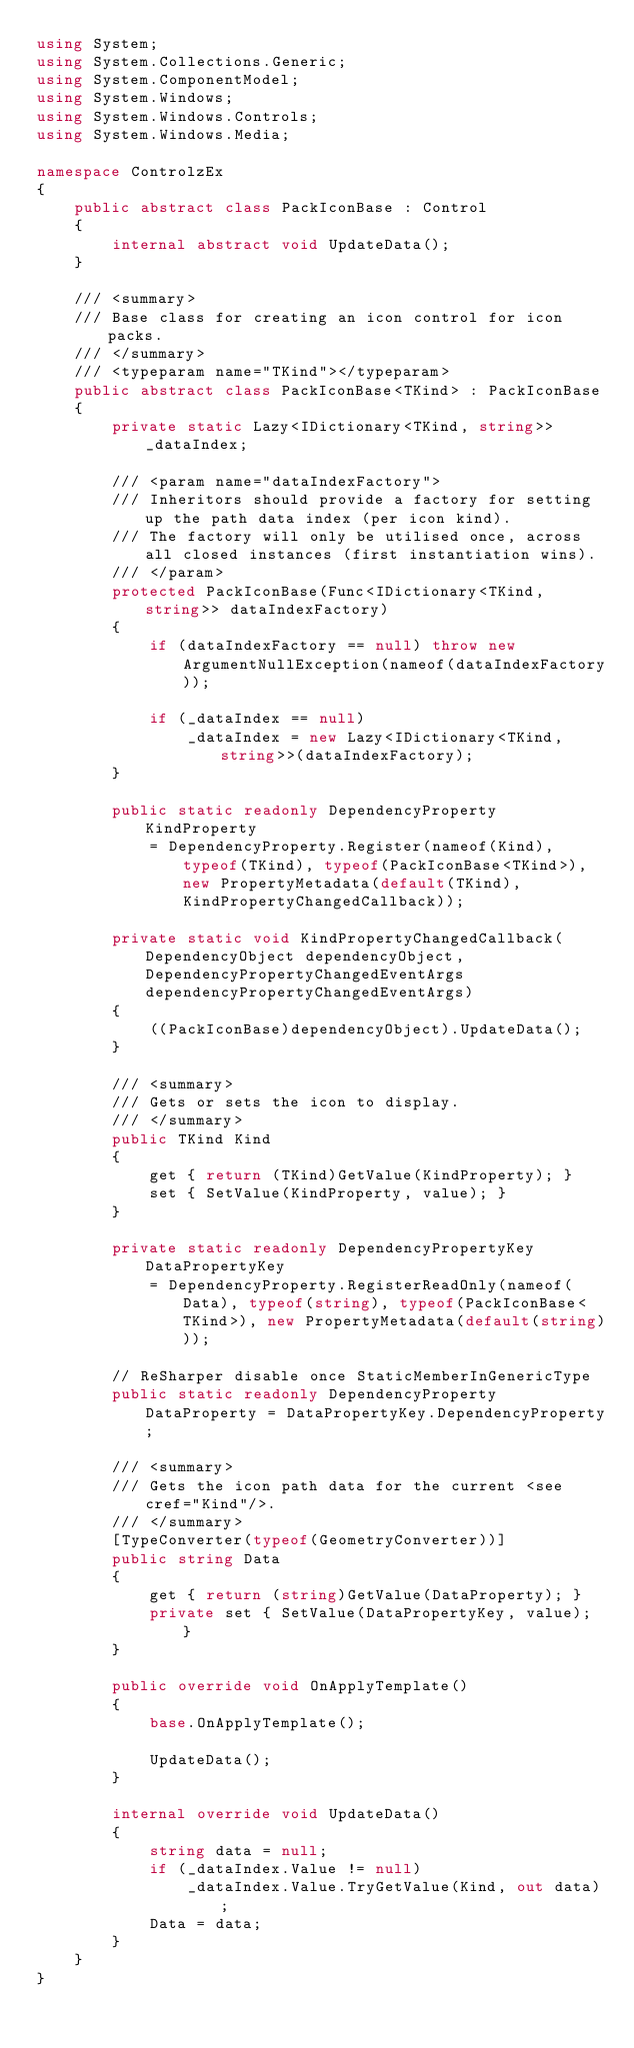Convert code to text. <code><loc_0><loc_0><loc_500><loc_500><_C#_>using System;
using System.Collections.Generic;
using System.ComponentModel;
using System.Windows;
using System.Windows.Controls;
using System.Windows.Media;

namespace ControlzEx
{
    public abstract class PackIconBase : Control
    {
        internal abstract void UpdateData();
    }

    /// <summary>
    /// Base class for creating an icon control for icon packs.
    /// </summary>
    /// <typeparam name="TKind"></typeparam>
    public abstract class PackIconBase<TKind> : PackIconBase
    {
        private static Lazy<IDictionary<TKind, string>> _dataIndex;

        /// <param name="dataIndexFactory">
        /// Inheritors should provide a factory for setting up the path data index (per icon kind).
        /// The factory will only be utilised once, across all closed instances (first instantiation wins).
        /// </param>
        protected PackIconBase(Func<IDictionary<TKind, string>> dataIndexFactory)
        {
            if (dataIndexFactory == null) throw new ArgumentNullException(nameof(dataIndexFactory));

            if (_dataIndex == null)
                _dataIndex = new Lazy<IDictionary<TKind, string>>(dataIndexFactory);
        }

        public static readonly DependencyProperty KindProperty
            = DependencyProperty.Register(nameof(Kind), typeof(TKind), typeof(PackIconBase<TKind>), new PropertyMetadata(default(TKind), KindPropertyChangedCallback));

        private static void KindPropertyChangedCallback(DependencyObject dependencyObject, DependencyPropertyChangedEventArgs dependencyPropertyChangedEventArgs)
        {
            ((PackIconBase)dependencyObject).UpdateData();
        }

        /// <summary>
        /// Gets or sets the icon to display.
        /// </summary>
        public TKind Kind
        {
            get { return (TKind)GetValue(KindProperty); }
            set { SetValue(KindProperty, value); }
        }

        private static readonly DependencyPropertyKey DataPropertyKey
            = DependencyProperty.RegisterReadOnly(nameof(Data), typeof(string), typeof(PackIconBase<TKind>), new PropertyMetadata(default(string)));

        // ReSharper disable once StaticMemberInGenericType
        public static readonly DependencyProperty DataProperty = DataPropertyKey.DependencyProperty;

        /// <summary>
        /// Gets the icon path data for the current <see cref="Kind"/>.
        /// </summary>
        [TypeConverter(typeof(GeometryConverter))]
        public string Data
        {
            get { return (string)GetValue(DataProperty); }
            private set { SetValue(DataPropertyKey, value); }
        }

        public override void OnApplyTemplate()
        {
            base.OnApplyTemplate();

            UpdateData();
        }

        internal override void UpdateData()
        {
            string data = null;
            if (_dataIndex.Value != null)
                _dataIndex.Value.TryGetValue(Kind, out data);
            Data = data;
        }
    }
}
</code> 